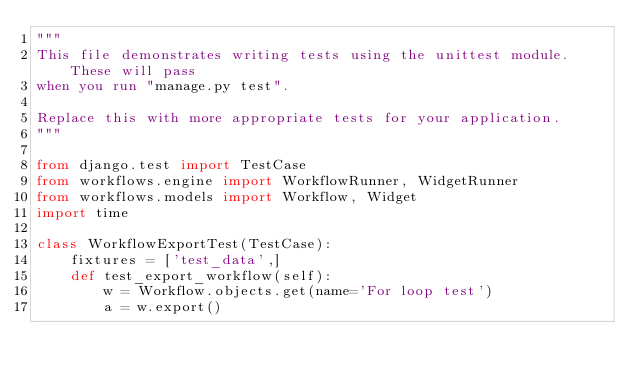<code> <loc_0><loc_0><loc_500><loc_500><_Python_>"""
This file demonstrates writing tests using the unittest module. These will pass
when you run "manage.py test".

Replace this with more appropriate tests for your application.
"""

from django.test import TestCase
from workflows.engine import WorkflowRunner, WidgetRunner
from workflows.models import Workflow, Widget
import time

class WorkflowExportTest(TestCase):
    fixtures = ['test_data',]
    def test_export_workflow(self):
        w = Workflow.objects.get(name='For loop test')
        a = w.export()</code> 